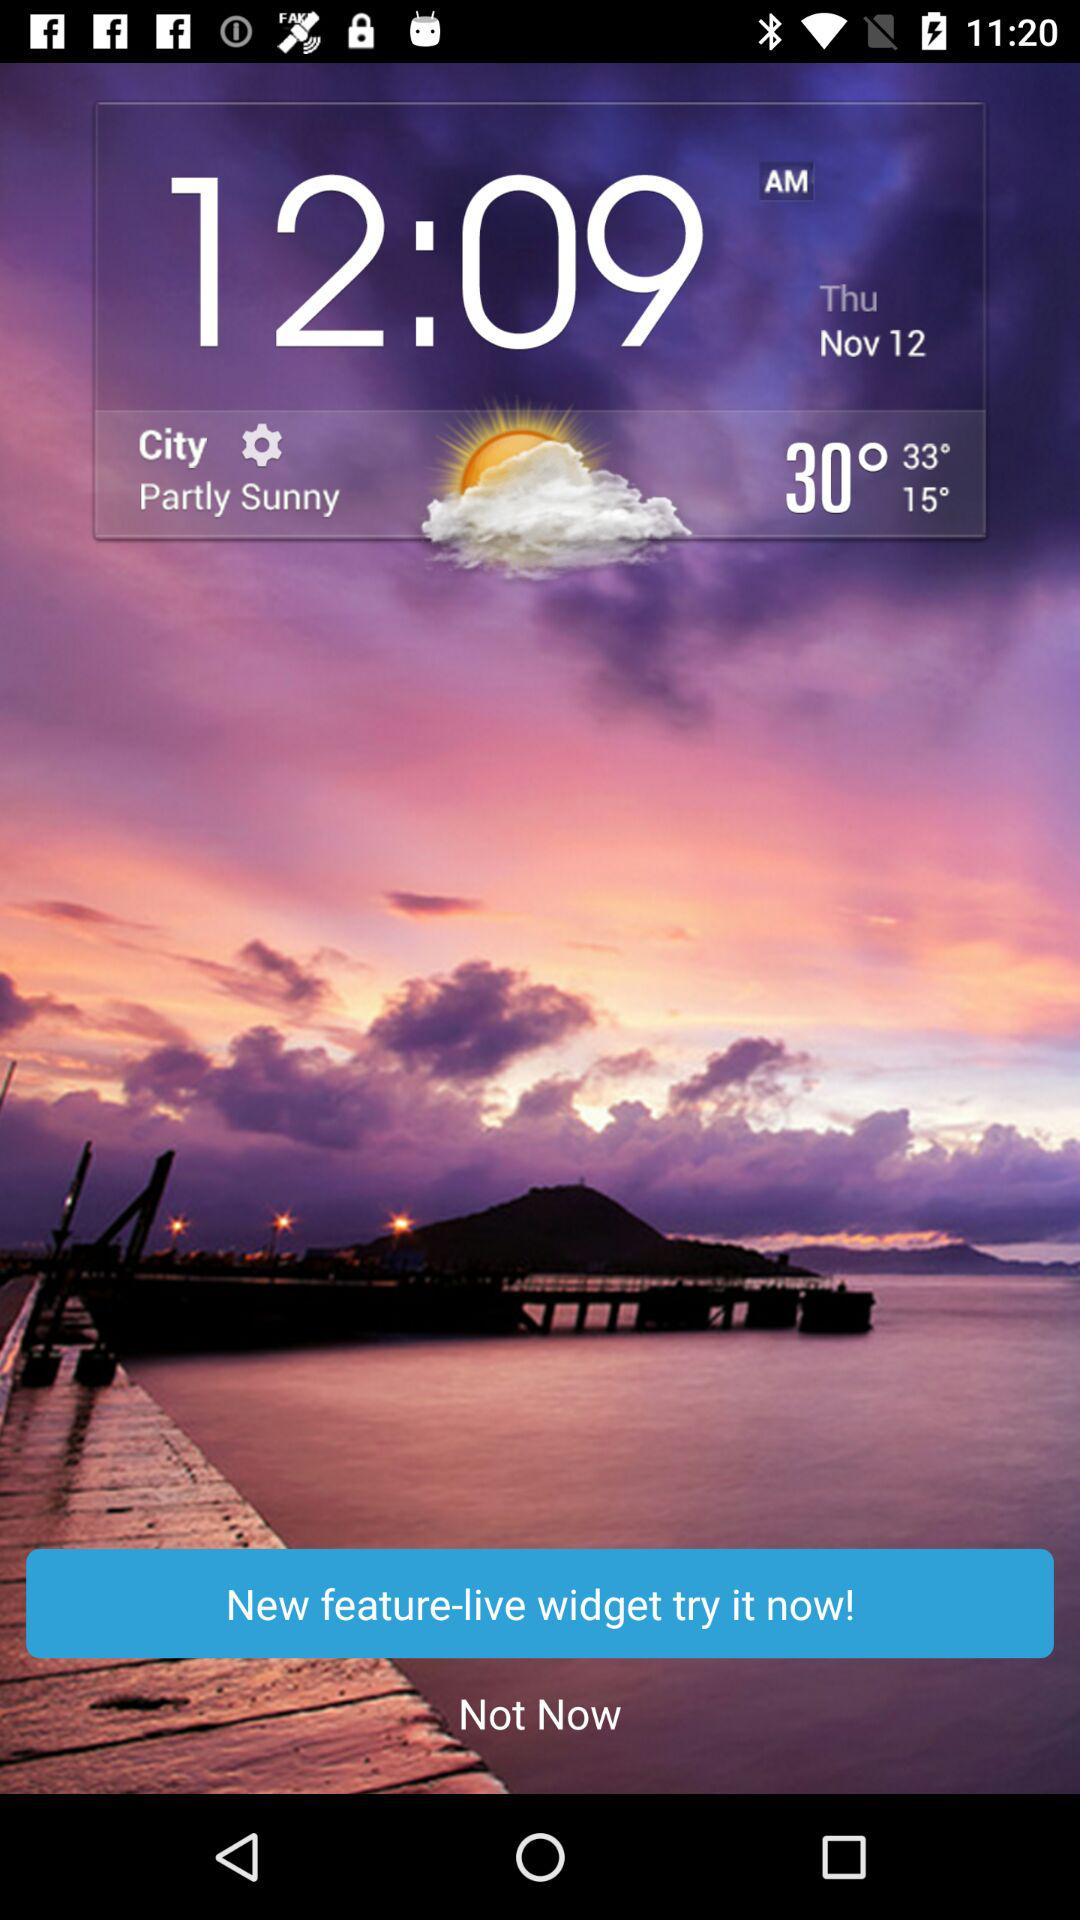Which city is this?
When the provided information is insufficient, respond with <no answer>. <no answer> 